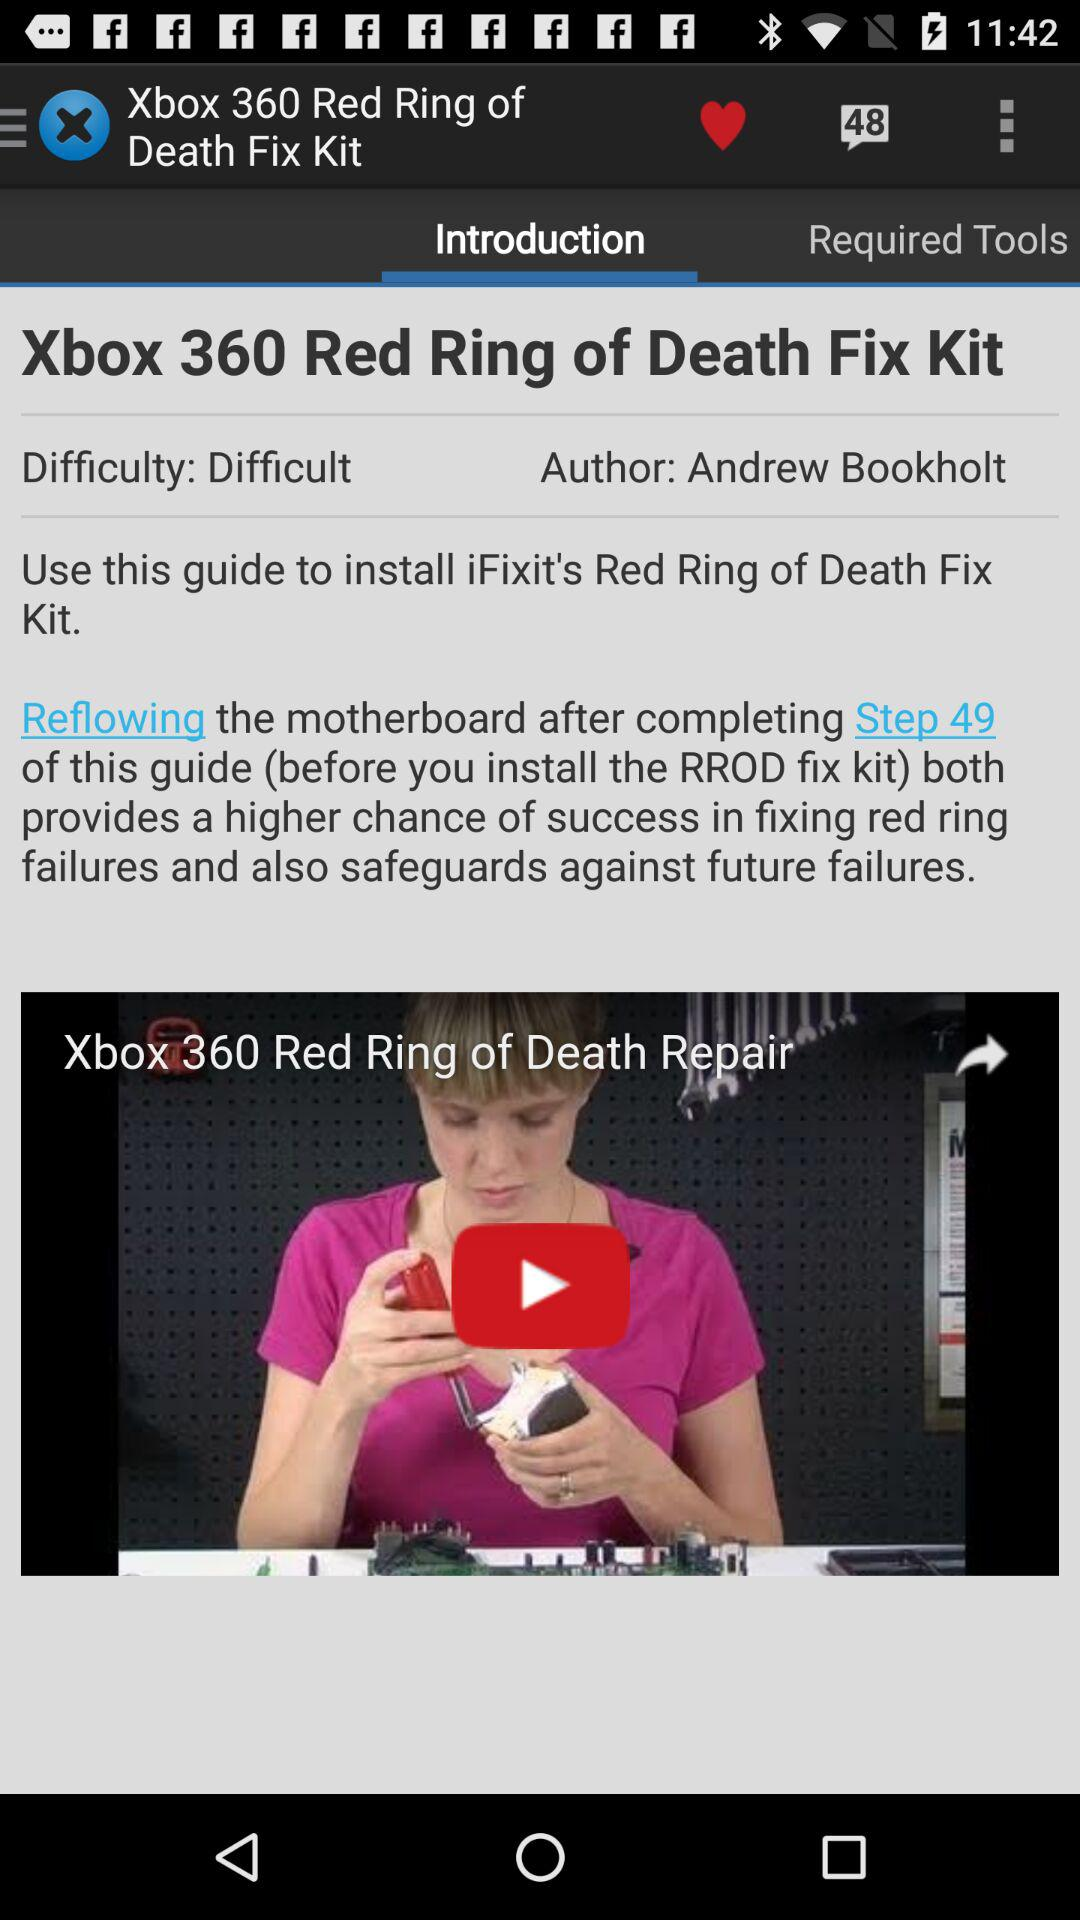For what use is the guide available? The guide is available for installing "iFixit's Red Ring of Death Fix Kit". 